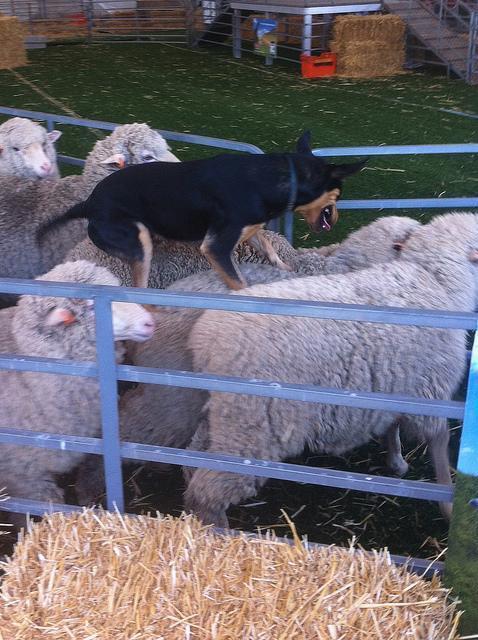How many sheep are in the photo?
Give a very brief answer. 5. 